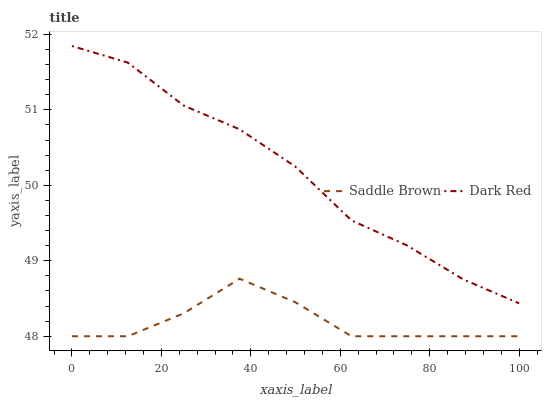Does Saddle Brown have the minimum area under the curve?
Answer yes or no. Yes. Does Dark Red have the maximum area under the curve?
Answer yes or no. Yes. Does Saddle Brown have the maximum area under the curve?
Answer yes or no. No. Is Dark Red the smoothest?
Answer yes or no. Yes. Is Saddle Brown the roughest?
Answer yes or no. Yes. Is Saddle Brown the smoothest?
Answer yes or no. No. Does Saddle Brown have the lowest value?
Answer yes or no. Yes. Does Dark Red have the highest value?
Answer yes or no. Yes. Does Saddle Brown have the highest value?
Answer yes or no. No. Is Saddle Brown less than Dark Red?
Answer yes or no. Yes. Is Dark Red greater than Saddle Brown?
Answer yes or no. Yes. Does Saddle Brown intersect Dark Red?
Answer yes or no. No. 